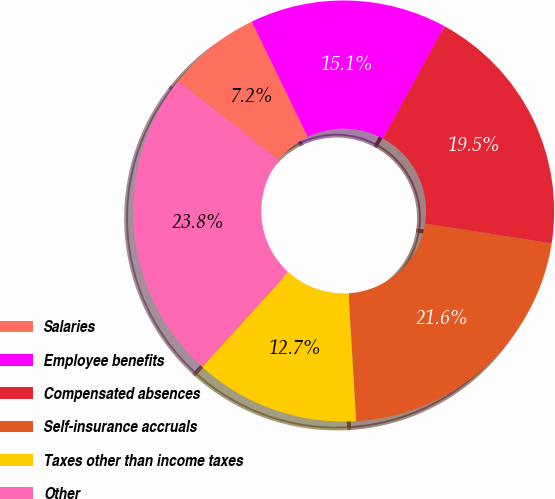Convert chart to OTSL. <chart><loc_0><loc_0><loc_500><loc_500><pie_chart><fcel>Salaries<fcel>Employee benefits<fcel>Compensated absences<fcel>Self-insurance accruals<fcel>Taxes other than income taxes<fcel>Other<nl><fcel>7.23%<fcel>15.13%<fcel>19.51%<fcel>21.6%<fcel>12.69%<fcel>23.85%<nl></chart> 